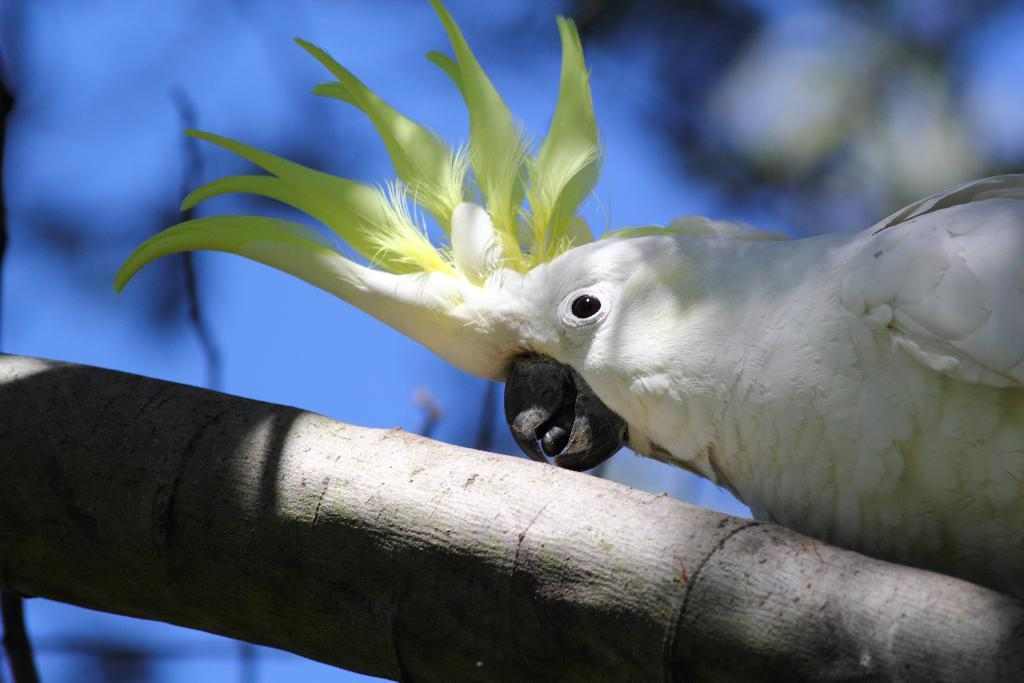What is the main subject of the picture? The main subject of the picture is a bird. Where is the bird located in the image? The bird is on a branch. What type of parcel is the bird holding in the image? There is no parcel present in the image; the bird is simply perched on a branch. 